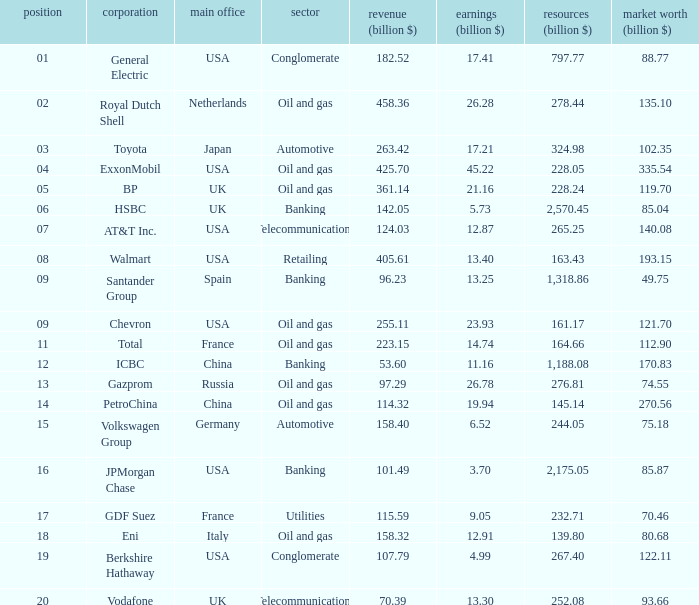Name the lowest Market Value (billion $) which has Assets (billion $) larger than 276.81, and a Company of toyota, and Profits (billion $) larger than 17.21? None. 